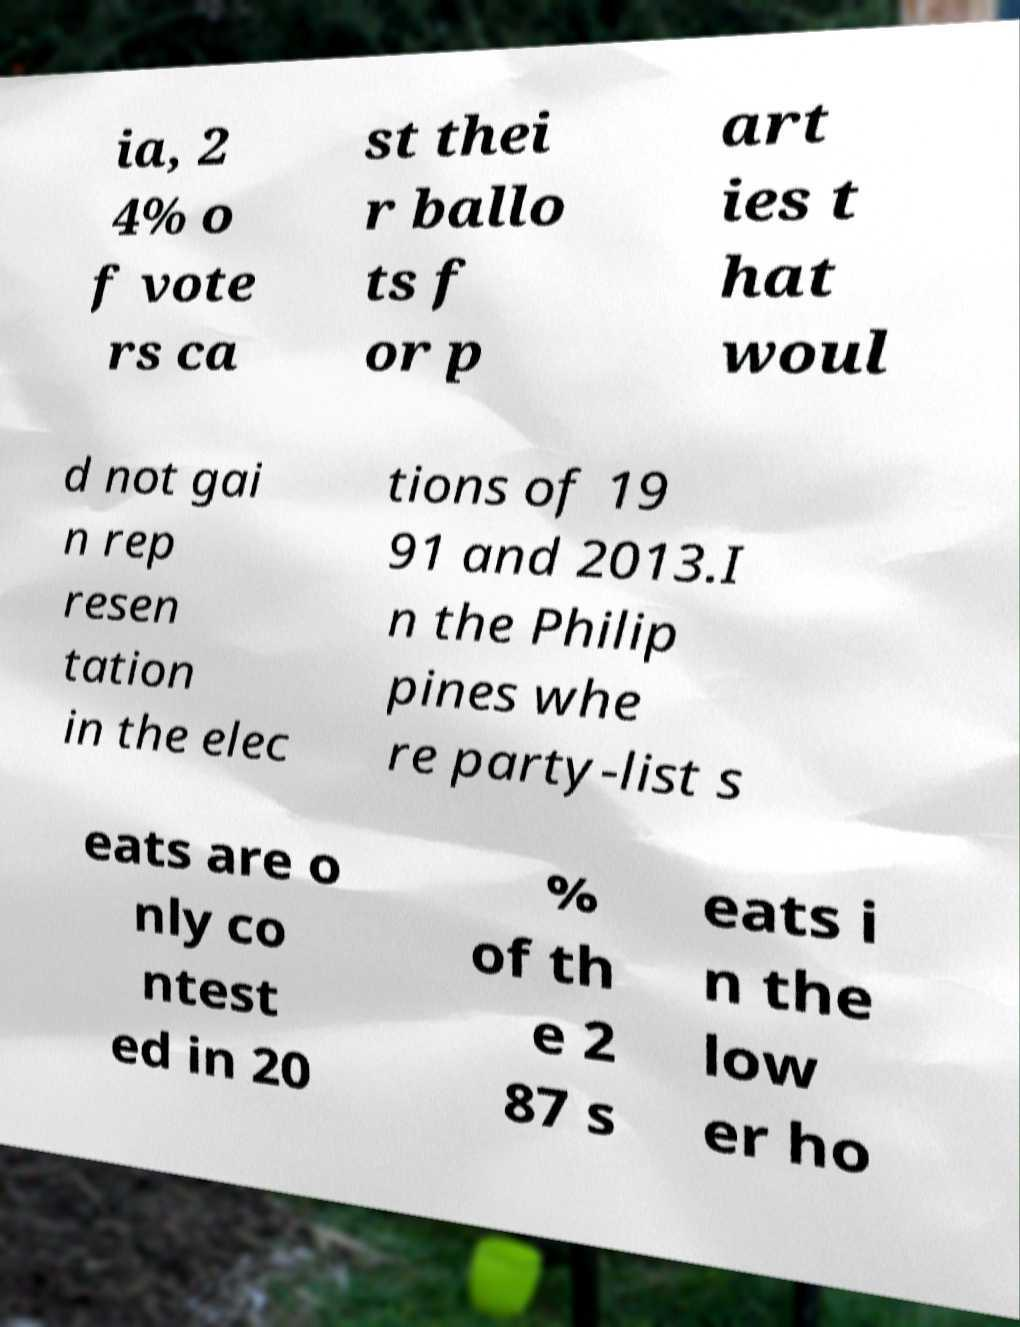Please identify and transcribe the text found in this image. ia, 2 4% o f vote rs ca st thei r ballo ts f or p art ies t hat woul d not gai n rep resen tation in the elec tions of 19 91 and 2013.I n the Philip pines whe re party-list s eats are o nly co ntest ed in 20 % of th e 2 87 s eats i n the low er ho 